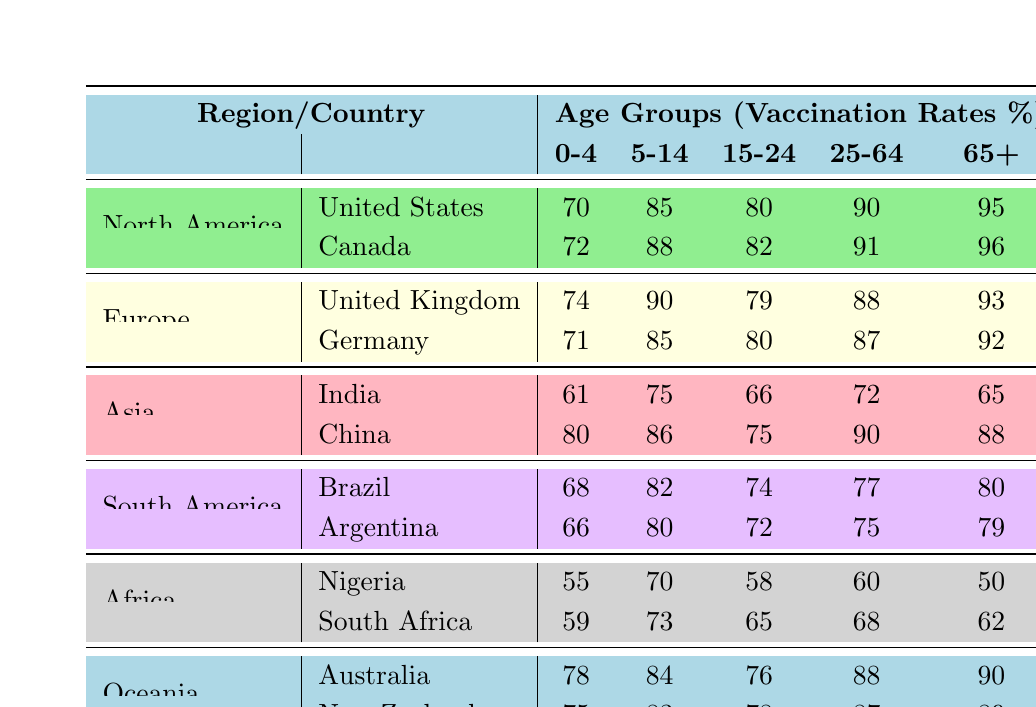What is the vaccination rate for the 25-64 age group in Canada? The table shows that Canada's vaccination rate for the 25-64 age group is 91%.
Answer: 91 Which country has the highest vaccination rate for the 0-4 age group? Comparing the 0-4 age group rates across all countries, China has the highest rate at 80%.
Answer: China What is the average vaccination rate for the 65 and above age group in South America? The rates for the 65 and above age group are 80% for Brazil and 79% for Argentina. The average is (80 + 79)/2 = 79.5%.
Answer: 79.5 Is the vaccination rate for the 15-24 age group in Germany higher than that in the United Kingdom? The table indicates that Germany has a rate of 80% while the United Kingdom has a rate of 79% for the 15-24 age group. Therefore, yes, Germany's rate is higher.
Answer: Yes What is the difference in vaccination rates for the 5-14 age group between Australia and India? The rate for Australia in the 5-14 age group is 84%, while for India it is 75%. The difference is 84 - 75 = 9%.
Answer: 9 Which region has the lowest vaccination rate for the 0-4 age group? The table shows that for the 0-4 age group, Nigeria has the lowest vaccination rate at 55%.
Answer: Nigeria What is the total vaccination rate for the 25-64 age group across all countries in Europe? Summing the rates for the 25-64 age group in Europe: UK (88) + Germany (87) = 175%.
Answer: 175 Is the vaccination rate for the 0-4 age group in South Africa greater than that in Nigeria? The table shows that South Africa's rate is 59% and Nigeria's is 55%. Thus, the statement is true.
Answer: Yes What percentage of the 15-24 age group in Brazil is vaccinated compared to the average of all countries for the same age group? The vaccination rate for Brazil's 15-24 age group is 74%. To find the average, add all values in the column for that age group: (80 + 79 + 66 + 75 + 74 + 65) = 439; divide by 6 gives approximately 73.17%. So, 74% is above average.
Answer: Above average 